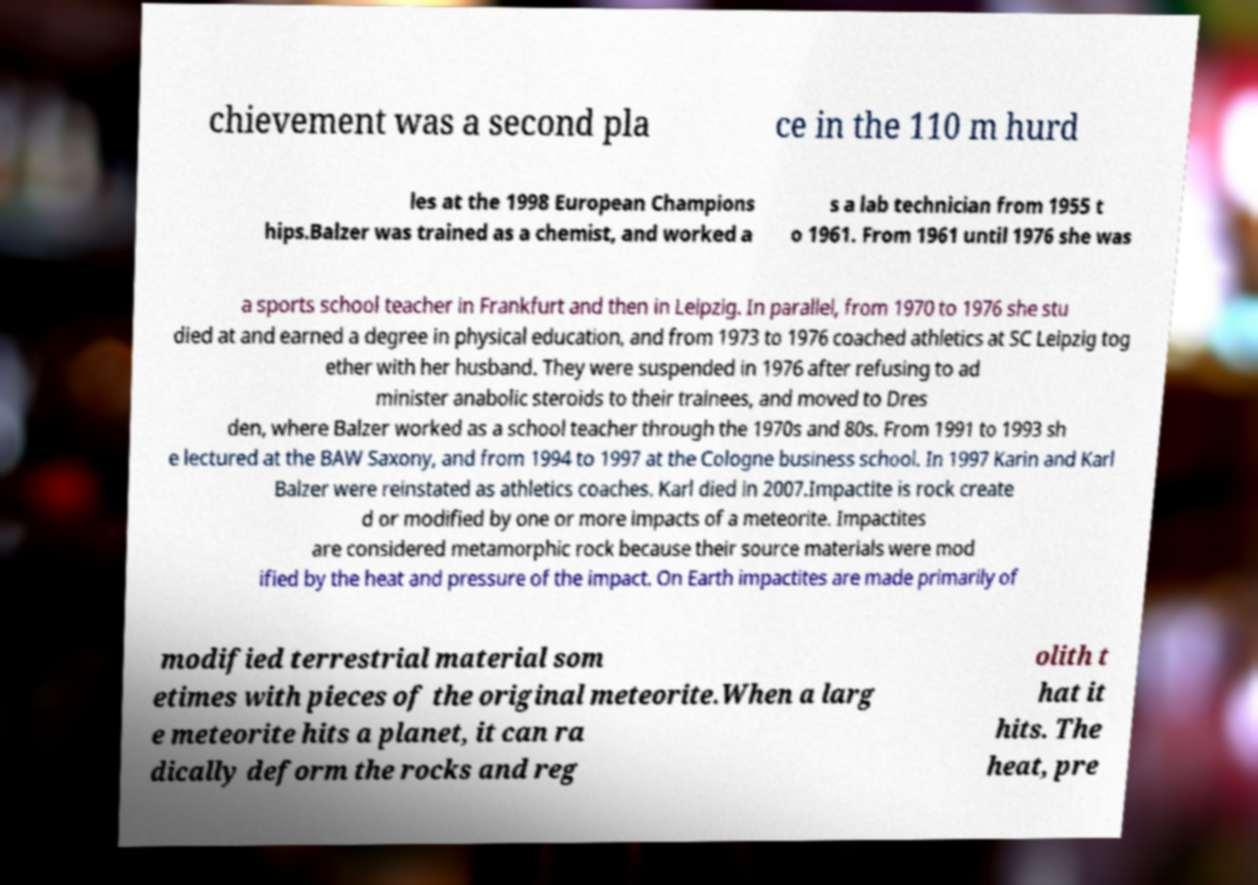Can you read and provide the text displayed in the image?This photo seems to have some interesting text. Can you extract and type it out for me? chievement was a second pla ce in the 110 m hurd les at the 1998 European Champions hips.Balzer was trained as a chemist, and worked a s a lab technician from 1955 t o 1961. From 1961 until 1976 she was a sports school teacher in Frankfurt and then in Leipzig. In parallel, from 1970 to 1976 she stu died at and earned a degree in physical education, and from 1973 to 1976 coached athletics at SC Leipzig tog ether with her husband. They were suspended in 1976 after refusing to ad minister anabolic steroids to their trainees, and moved to Dres den, where Balzer worked as a school teacher through the 1970s and 80s. From 1991 to 1993 sh e lectured at the BAW Saxony, and from 1994 to 1997 at the Cologne business school. In 1997 Karin and Karl Balzer were reinstated as athletics coaches. Karl died in 2007.Impactite is rock create d or modified by one or more impacts of a meteorite. Impactites are considered metamorphic rock because their source materials were mod ified by the heat and pressure of the impact. On Earth impactites are made primarily of modified terrestrial material som etimes with pieces of the original meteorite.When a larg e meteorite hits a planet, it can ra dically deform the rocks and reg olith t hat it hits. The heat, pre 